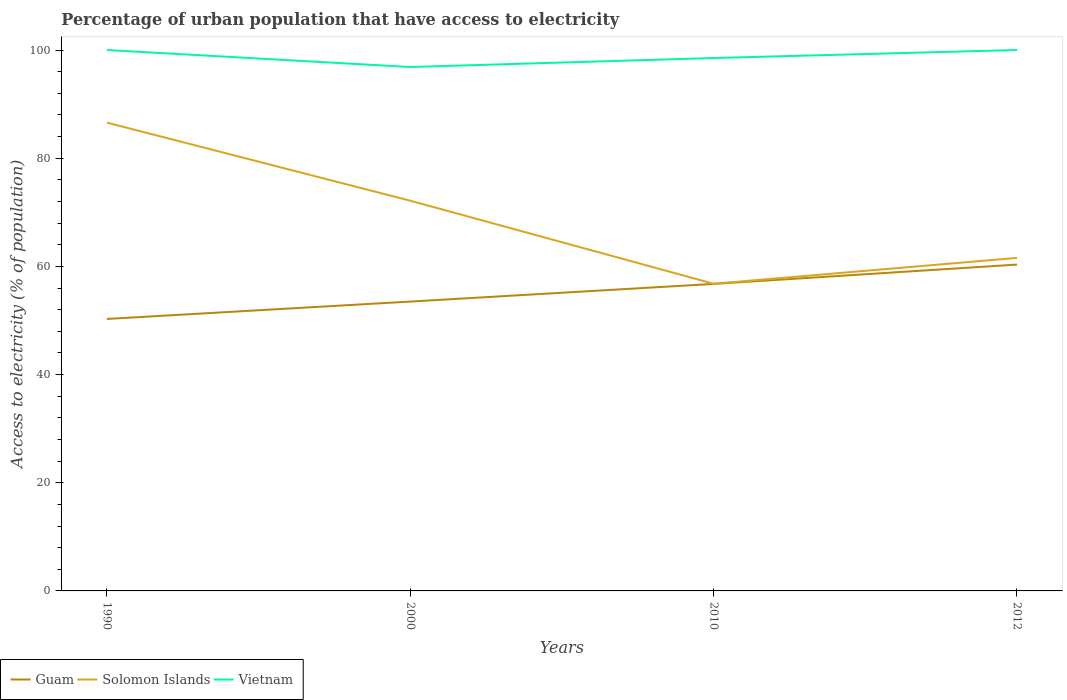Across all years, what is the maximum percentage of urban population that have access to electricity in Guam?
Your answer should be very brief. 50.28. What is the total percentage of urban population that have access to electricity in Guam in the graph?
Keep it short and to the point. -10.05. What is the difference between the highest and the second highest percentage of urban population that have access to electricity in Guam?
Ensure brevity in your answer.  10.05. What is the difference between the highest and the lowest percentage of urban population that have access to electricity in Vietnam?
Offer a terse response. 2. How many lines are there?
Your answer should be compact. 3. How many years are there in the graph?
Offer a terse response. 4. What is the difference between two consecutive major ticks on the Y-axis?
Your answer should be compact. 20. Are the values on the major ticks of Y-axis written in scientific E-notation?
Give a very brief answer. No. Does the graph contain grids?
Your answer should be very brief. No. How many legend labels are there?
Offer a very short reply. 3. How are the legend labels stacked?
Your answer should be compact. Horizontal. What is the title of the graph?
Provide a short and direct response. Percentage of urban population that have access to electricity. What is the label or title of the Y-axis?
Keep it short and to the point. Access to electricity (% of population). What is the Access to electricity (% of population) of Guam in 1990?
Offer a very short reply. 50.28. What is the Access to electricity (% of population) of Solomon Islands in 1990?
Give a very brief answer. 86.58. What is the Access to electricity (% of population) of Vietnam in 1990?
Your response must be concise. 100. What is the Access to electricity (% of population) in Guam in 2000?
Give a very brief answer. 53.49. What is the Access to electricity (% of population) in Solomon Islands in 2000?
Your response must be concise. 72.14. What is the Access to electricity (% of population) of Vietnam in 2000?
Your response must be concise. 96.86. What is the Access to electricity (% of population) in Guam in 2010?
Offer a very short reply. 56.76. What is the Access to electricity (% of population) of Solomon Islands in 2010?
Your response must be concise. 56.79. What is the Access to electricity (% of population) in Vietnam in 2010?
Make the answer very short. 98.52. What is the Access to electricity (% of population) in Guam in 2012?
Your answer should be very brief. 60.33. What is the Access to electricity (% of population) in Solomon Islands in 2012?
Offer a very short reply. 61.57. Across all years, what is the maximum Access to electricity (% of population) of Guam?
Give a very brief answer. 60.33. Across all years, what is the maximum Access to electricity (% of population) in Solomon Islands?
Give a very brief answer. 86.58. Across all years, what is the minimum Access to electricity (% of population) of Guam?
Provide a short and direct response. 50.28. Across all years, what is the minimum Access to electricity (% of population) in Solomon Islands?
Offer a terse response. 56.79. Across all years, what is the minimum Access to electricity (% of population) in Vietnam?
Offer a terse response. 96.86. What is the total Access to electricity (% of population) of Guam in the graph?
Your answer should be very brief. 220.87. What is the total Access to electricity (% of population) of Solomon Islands in the graph?
Give a very brief answer. 277.08. What is the total Access to electricity (% of population) in Vietnam in the graph?
Provide a succinct answer. 395.38. What is the difference between the Access to electricity (% of population) of Guam in 1990 and that in 2000?
Your answer should be compact. -3.21. What is the difference between the Access to electricity (% of population) in Solomon Islands in 1990 and that in 2000?
Offer a terse response. 14.44. What is the difference between the Access to electricity (% of population) in Vietnam in 1990 and that in 2000?
Ensure brevity in your answer.  3.14. What is the difference between the Access to electricity (% of population) in Guam in 1990 and that in 2010?
Provide a short and direct response. -6.48. What is the difference between the Access to electricity (% of population) of Solomon Islands in 1990 and that in 2010?
Your answer should be compact. 29.79. What is the difference between the Access to electricity (% of population) of Vietnam in 1990 and that in 2010?
Provide a short and direct response. 1.48. What is the difference between the Access to electricity (% of population) of Guam in 1990 and that in 2012?
Make the answer very short. -10.05. What is the difference between the Access to electricity (% of population) of Solomon Islands in 1990 and that in 2012?
Your answer should be very brief. 25.01. What is the difference between the Access to electricity (% of population) in Guam in 2000 and that in 2010?
Provide a succinct answer. -3.27. What is the difference between the Access to electricity (% of population) of Solomon Islands in 2000 and that in 2010?
Offer a terse response. 15.35. What is the difference between the Access to electricity (% of population) of Vietnam in 2000 and that in 2010?
Offer a terse response. -1.66. What is the difference between the Access to electricity (% of population) in Guam in 2000 and that in 2012?
Give a very brief answer. -6.84. What is the difference between the Access to electricity (% of population) of Solomon Islands in 2000 and that in 2012?
Your response must be concise. 10.57. What is the difference between the Access to electricity (% of population) of Vietnam in 2000 and that in 2012?
Offer a terse response. -3.14. What is the difference between the Access to electricity (% of population) of Guam in 2010 and that in 2012?
Your response must be concise. -3.58. What is the difference between the Access to electricity (% of population) of Solomon Islands in 2010 and that in 2012?
Ensure brevity in your answer.  -4.78. What is the difference between the Access to electricity (% of population) of Vietnam in 2010 and that in 2012?
Give a very brief answer. -1.48. What is the difference between the Access to electricity (% of population) in Guam in 1990 and the Access to electricity (% of population) in Solomon Islands in 2000?
Your response must be concise. -21.86. What is the difference between the Access to electricity (% of population) in Guam in 1990 and the Access to electricity (% of population) in Vietnam in 2000?
Make the answer very short. -46.57. What is the difference between the Access to electricity (% of population) of Solomon Islands in 1990 and the Access to electricity (% of population) of Vietnam in 2000?
Your answer should be compact. -10.28. What is the difference between the Access to electricity (% of population) of Guam in 1990 and the Access to electricity (% of population) of Solomon Islands in 2010?
Your answer should be very brief. -6.5. What is the difference between the Access to electricity (% of population) in Guam in 1990 and the Access to electricity (% of population) in Vietnam in 2010?
Keep it short and to the point. -48.24. What is the difference between the Access to electricity (% of population) in Solomon Islands in 1990 and the Access to electricity (% of population) in Vietnam in 2010?
Your answer should be very brief. -11.94. What is the difference between the Access to electricity (% of population) of Guam in 1990 and the Access to electricity (% of population) of Solomon Islands in 2012?
Ensure brevity in your answer.  -11.29. What is the difference between the Access to electricity (% of population) of Guam in 1990 and the Access to electricity (% of population) of Vietnam in 2012?
Your answer should be very brief. -49.72. What is the difference between the Access to electricity (% of population) in Solomon Islands in 1990 and the Access to electricity (% of population) in Vietnam in 2012?
Your response must be concise. -13.42. What is the difference between the Access to electricity (% of population) in Guam in 2000 and the Access to electricity (% of population) in Solomon Islands in 2010?
Ensure brevity in your answer.  -3.29. What is the difference between the Access to electricity (% of population) of Guam in 2000 and the Access to electricity (% of population) of Vietnam in 2010?
Your answer should be very brief. -45.03. What is the difference between the Access to electricity (% of population) in Solomon Islands in 2000 and the Access to electricity (% of population) in Vietnam in 2010?
Your answer should be compact. -26.38. What is the difference between the Access to electricity (% of population) of Guam in 2000 and the Access to electricity (% of population) of Solomon Islands in 2012?
Keep it short and to the point. -8.08. What is the difference between the Access to electricity (% of population) of Guam in 2000 and the Access to electricity (% of population) of Vietnam in 2012?
Offer a terse response. -46.51. What is the difference between the Access to electricity (% of population) in Solomon Islands in 2000 and the Access to electricity (% of population) in Vietnam in 2012?
Give a very brief answer. -27.86. What is the difference between the Access to electricity (% of population) in Guam in 2010 and the Access to electricity (% of population) in Solomon Islands in 2012?
Provide a succinct answer. -4.81. What is the difference between the Access to electricity (% of population) of Guam in 2010 and the Access to electricity (% of population) of Vietnam in 2012?
Give a very brief answer. -43.24. What is the difference between the Access to electricity (% of population) of Solomon Islands in 2010 and the Access to electricity (% of population) of Vietnam in 2012?
Your answer should be very brief. -43.21. What is the average Access to electricity (% of population) of Guam per year?
Provide a succinct answer. 55.22. What is the average Access to electricity (% of population) of Solomon Islands per year?
Offer a terse response. 69.27. What is the average Access to electricity (% of population) in Vietnam per year?
Give a very brief answer. 98.84. In the year 1990, what is the difference between the Access to electricity (% of population) in Guam and Access to electricity (% of population) in Solomon Islands?
Your answer should be compact. -36.3. In the year 1990, what is the difference between the Access to electricity (% of population) in Guam and Access to electricity (% of population) in Vietnam?
Give a very brief answer. -49.72. In the year 1990, what is the difference between the Access to electricity (% of population) in Solomon Islands and Access to electricity (% of population) in Vietnam?
Make the answer very short. -13.42. In the year 2000, what is the difference between the Access to electricity (% of population) of Guam and Access to electricity (% of population) of Solomon Islands?
Make the answer very short. -18.65. In the year 2000, what is the difference between the Access to electricity (% of population) in Guam and Access to electricity (% of population) in Vietnam?
Your answer should be compact. -43.36. In the year 2000, what is the difference between the Access to electricity (% of population) of Solomon Islands and Access to electricity (% of population) of Vietnam?
Offer a terse response. -24.71. In the year 2010, what is the difference between the Access to electricity (% of population) in Guam and Access to electricity (% of population) in Solomon Islands?
Ensure brevity in your answer.  -0.03. In the year 2010, what is the difference between the Access to electricity (% of population) of Guam and Access to electricity (% of population) of Vietnam?
Your answer should be very brief. -41.76. In the year 2010, what is the difference between the Access to electricity (% of population) of Solomon Islands and Access to electricity (% of population) of Vietnam?
Offer a terse response. -41.73. In the year 2012, what is the difference between the Access to electricity (% of population) of Guam and Access to electricity (% of population) of Solomon Islands?
Give a very brief answer. -1.24. In the year 2012, what is the difference between the Access to electricity (% of population) of Guam and Access to electricity (% of population) of Vietnam?
Provide a succinct answer. -39.67. In the year 2012, what is the difference between the Access to electricity (% of population) of Solomon Islands and Access to electricity (% of population) of Vietnam?
Offer a very short reply. -38.43. What is the ratio of the Access to electricity (% of population) of Guam in 1990 to that in 2000?
Offer a very short reply. 0.94. What is the ratio of the Access to electricity (% of population) of Solomon Islands in 1990 to that in 2000?
Give a very brief answer. 1.2. What is the ratio of the Access to electricity (% of population) of Vietnam in 1990 to that in 2000?
Ensure brevity in your answer.  1.03. What is the ratio of the Access to electricity (% of population) of Guam in 1990 to that in 2010?
Keep it short and to the point. 0.89. What is the ratio of the Access to electricity (% of population) of Solomon Islands in 1990 to that in 2010?
Provide a succinct answer. 1.52. What is the ratio of the Access to electricity (% of population) of Guam in 1990 to that in 2012?
Your answer should be very brief. 0.83. What is the ratio of the Access to electricity (% of population) of Solomon Islands in 1990 to that in 2012?
Your response must be concise. 1.41. What is the ratio of the Access to electricity (% of population) of Vietnam in 1990 to that in 2012?
Ensure brevity in your answer.  1. What is the ratio of the Access to electricity (% of population) of Guam in 2000 to that in 2010?
Provide a succinct answer. 0.94. What is the ratio of the Access to electricity (% of population) in Solomon Islands in 2000 to that in 2010?
Offer a terse response. 1.27. What is the ratio of the Access to electricity (% of population) of Vietnam in 2000 to that in 2010?
Your answer should be very brief. 0.98. What is the ratio of the Access to electricity (% of population) in Guam in 2000 to that in 2012?
Provide a succinct answer. 0.89. What is the ratio of the Access to electricity (% of population) of Solomon Islands in 2000 to that in 2012?
Make the answer very short. 1.17. What is the ratio of the Access to electricity (% of population) in Vietnam in 2000 to that in 2012?
Your answer should be compact. 0.97. What is the ratio of the Access to electricity (% of population) in Guam in 2010 to that in 2012?
Provide a short and direct response. 0.94. What is the ratio of the Access to electricity (% of population) in Solomon Islands in 2010 to that in 2012?
Offer a very short reply. 0.92. What is the ratio of the Access to electricity (% of population) of Vietnam in 2010 to that in 2012?
Ensure brevity in your answer.  0.99. What is the difference between the highest and the second highest Access to electricity (% of population) in Guam?
Your answer should be compact. 3.58. What is the difference between the highest and the second highest Access to electricity (% of population) in Solomon Islands?
Provide a succinct answer. 14.44. What is the difference between the highest and the lowest Access to electricity (% of population) in Guam?
Ensure brevity in your answer.  10.05. What is the difference between the highest and the lowest Access to electricity (% of population) in Solomon Islands?
Offer a very short reply. 29.79. What is the difference between the highest and the lowest Access to electricity (% of population) of Vietnam?
Your answer should be compact. 3.14. 